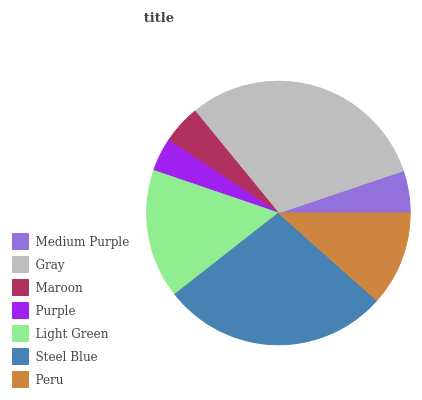Is Purple the minimum?
Answer yes or no. Yes. Is Gray the maximum?
Answer yes or no. Yes. Is Maroon the minimum?
Answer yes or no. No. Is Maroon the maximum?
Answer yes or no. No. Is Gray greater than Maroon?
Answer yes or no. Yes. Is Maroon less than Gray?
Answer yes or no. Yes. Is Maroon greater than Gray?
Answer yes or no. No. Is Gray less than Maroon?
Answer yes or no. No. Is Peru the high median?
Answer yes or no. Yes. Is Peru the low median?
Answer yes or no. Yes. Is Medium Purple the high median?
Answer yes or no. No. Is Purple the low median?
Answer yes or no. No. 